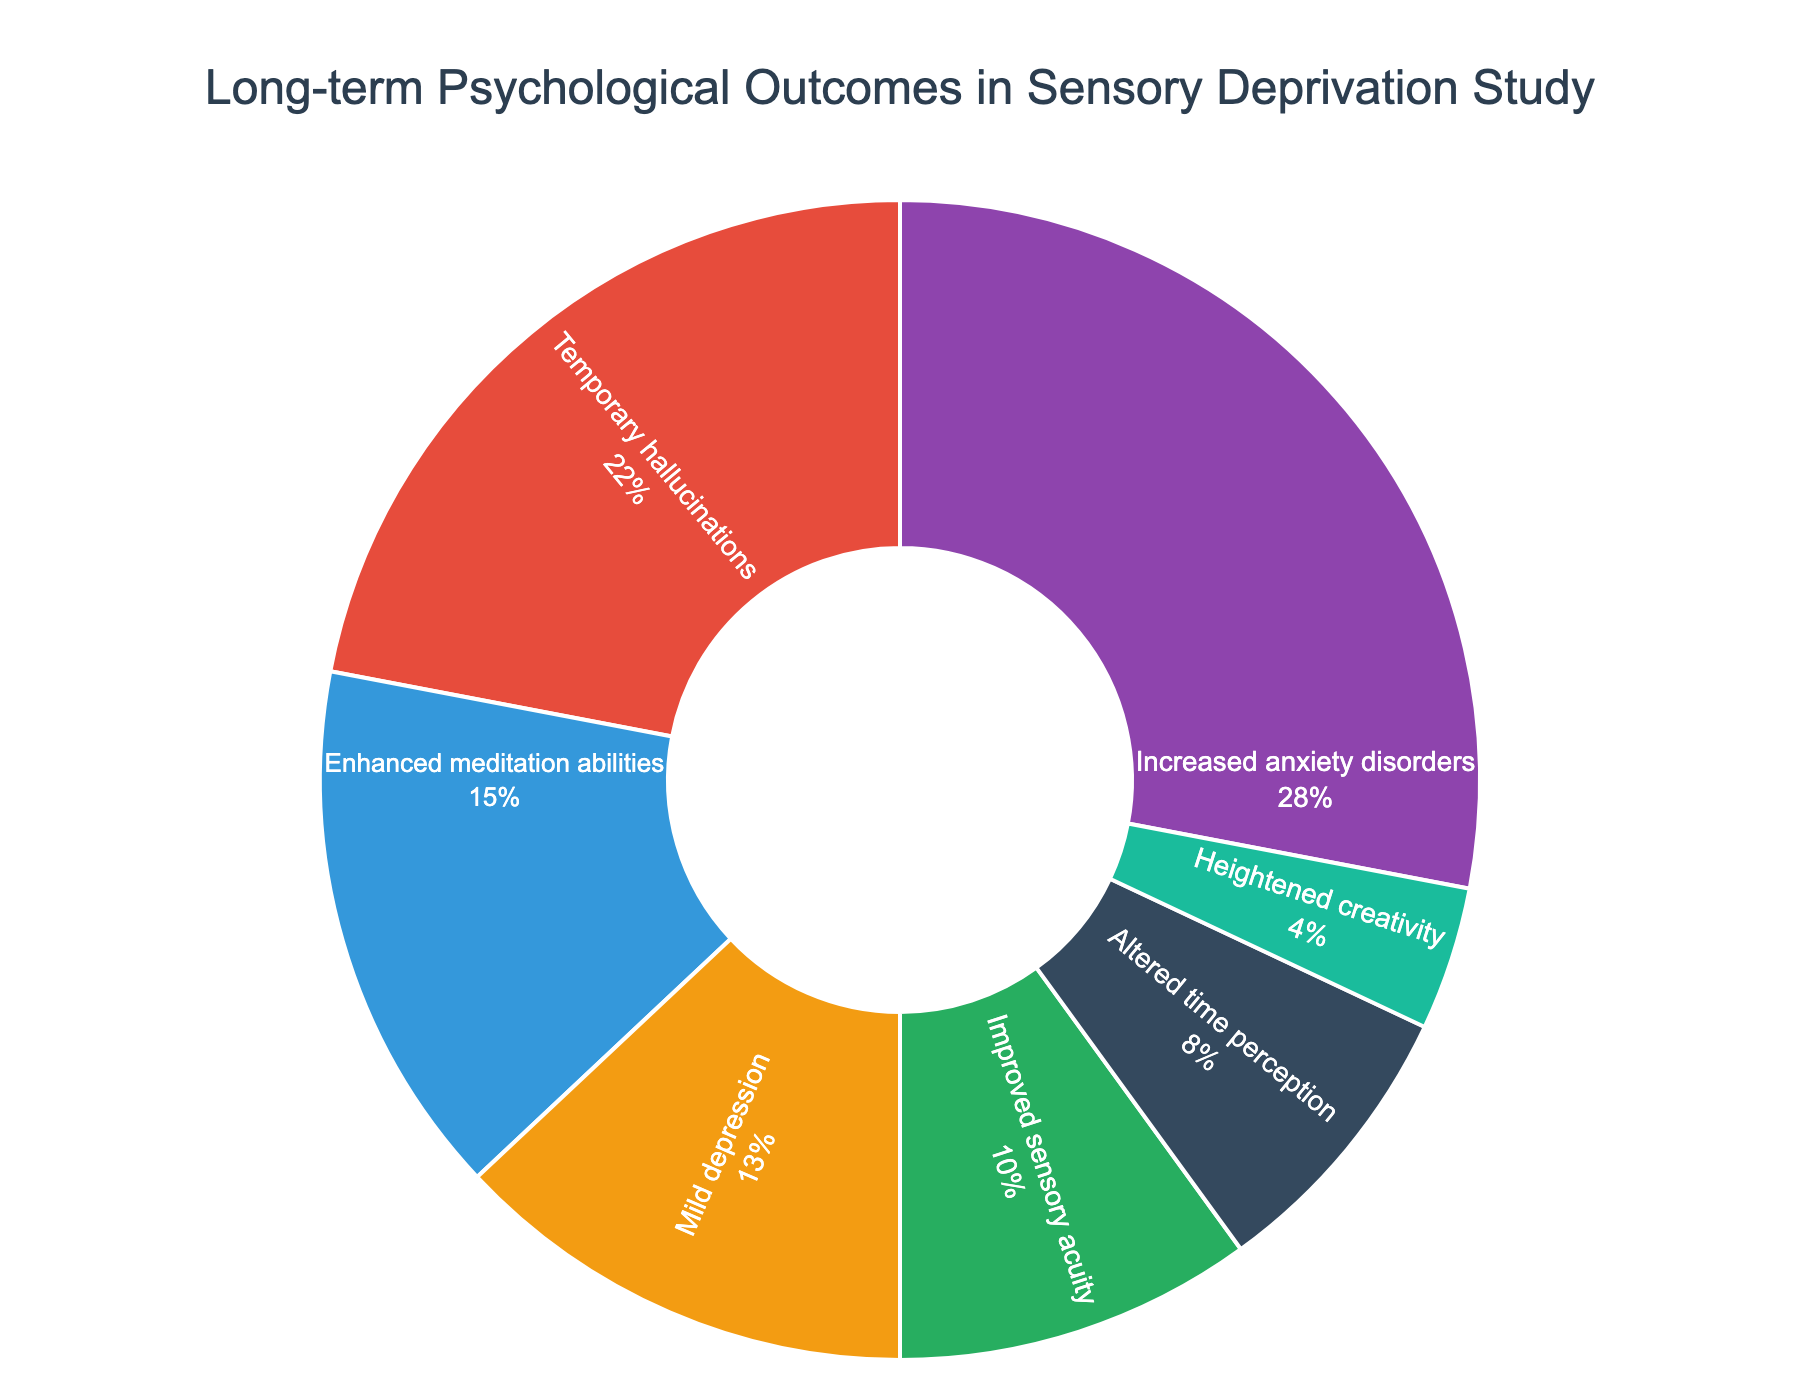What percentage of study participants experienced increased anxiety disorders? The pie chart indicates the percentage distribution of long-term psychological outcomes. By referring to the section labeled "Increased anxiety disorders", we see it accounts for 28% of the outcomes.
Answer: 28% Which outcome had the lowest percentage of participants? The pie chart shows different segments with their respective percentages. The smallest segment represents "Heightened creativity" with 4%.
Answer: Heightened creativity What is the combined percentage of participants who experienced either improved sensory acuity or heightened creativity? By looking at the pie chart, adding the percentages for "Improved sensory acuity" (10%) and "Heightened creativity" (4%) results in 10% + 4%.
Answer: 14% Are there more participants who experienced temporary hallucinations or mild depression? Comparing the segments, "Temporary hallucinations" accounts for 22%, while "Mild depression" accounts for 13%. Temporary hallucinations is the larger percentage.
Answer: Temporary hallucinations What is the color of the segment representing mild depression? Observing the color-related visual cues in the pie chart, the segment named "Mild depression" is represented with an orange-like color.
Answer: orange How does the percentage of participants with enhanced meditation abilities compare to those with altered time perception? Checking the respective segments in the pie chart, "Enhanced meditation abilities" shows 15% and "Altered time perception" shows 8%. Thus, "Enhanced meditation abilities" is higher.
Answer: Enhanced meditation abilities What is the difference in percentage between temporary hallucinations and heightened creativity? Looking at the pie chart, the percentage for "Temporary hallucinations" is 22% and for "Heightened creativity" is 4%. The difference is 22% - 4%.
Answer: 18% What is the total percentage of outcomes that had a positive psychological effect (enhanced meditation abilities, improved sensory acuity, heightened creativity)? Adding the percentages for "Enhanced meditation abilities" (15%), "Improved sensory acuity" (10%), and "Heightened creativity" (4%) gives 15% + 10% + 4%.
Answer: 29% Which segments are represented using purple and blue colors? Identifying the colors associated with segments, "Increased anxiety disorders" is represented in purple, and "Enhanced meditation abilities" in blue.
Answer: Increased anxiety disorders and Enhanced meditation abilities 